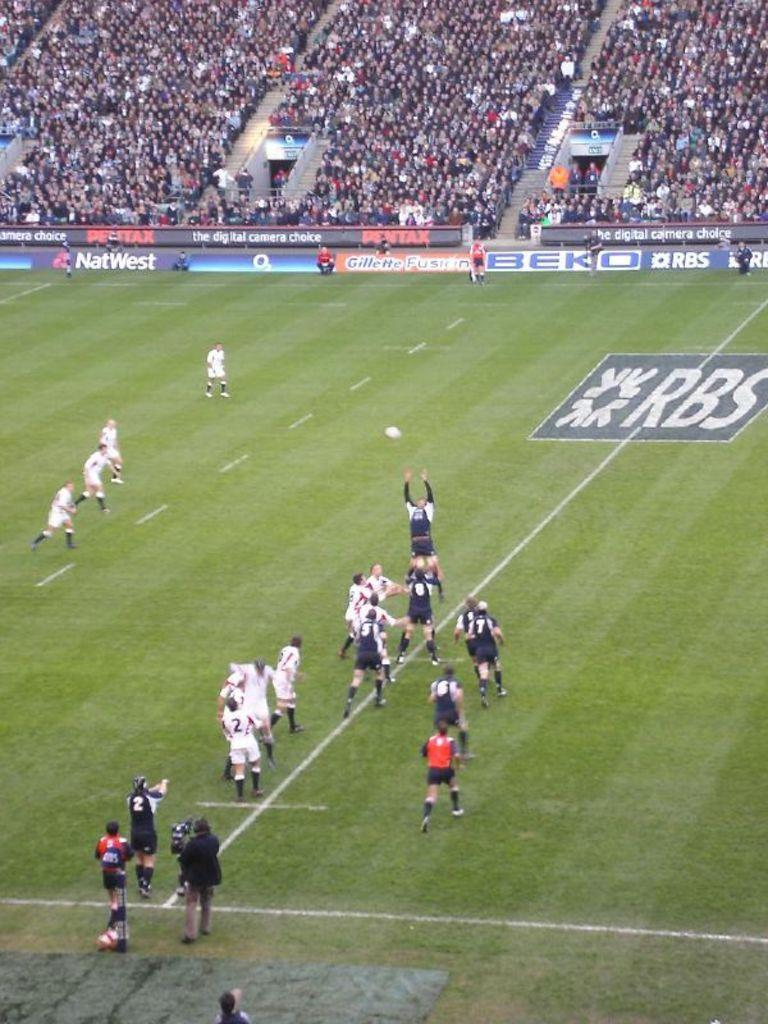Provide a one-sentence caption for the provided image. an RBS soccer field with players in mid game mode. 